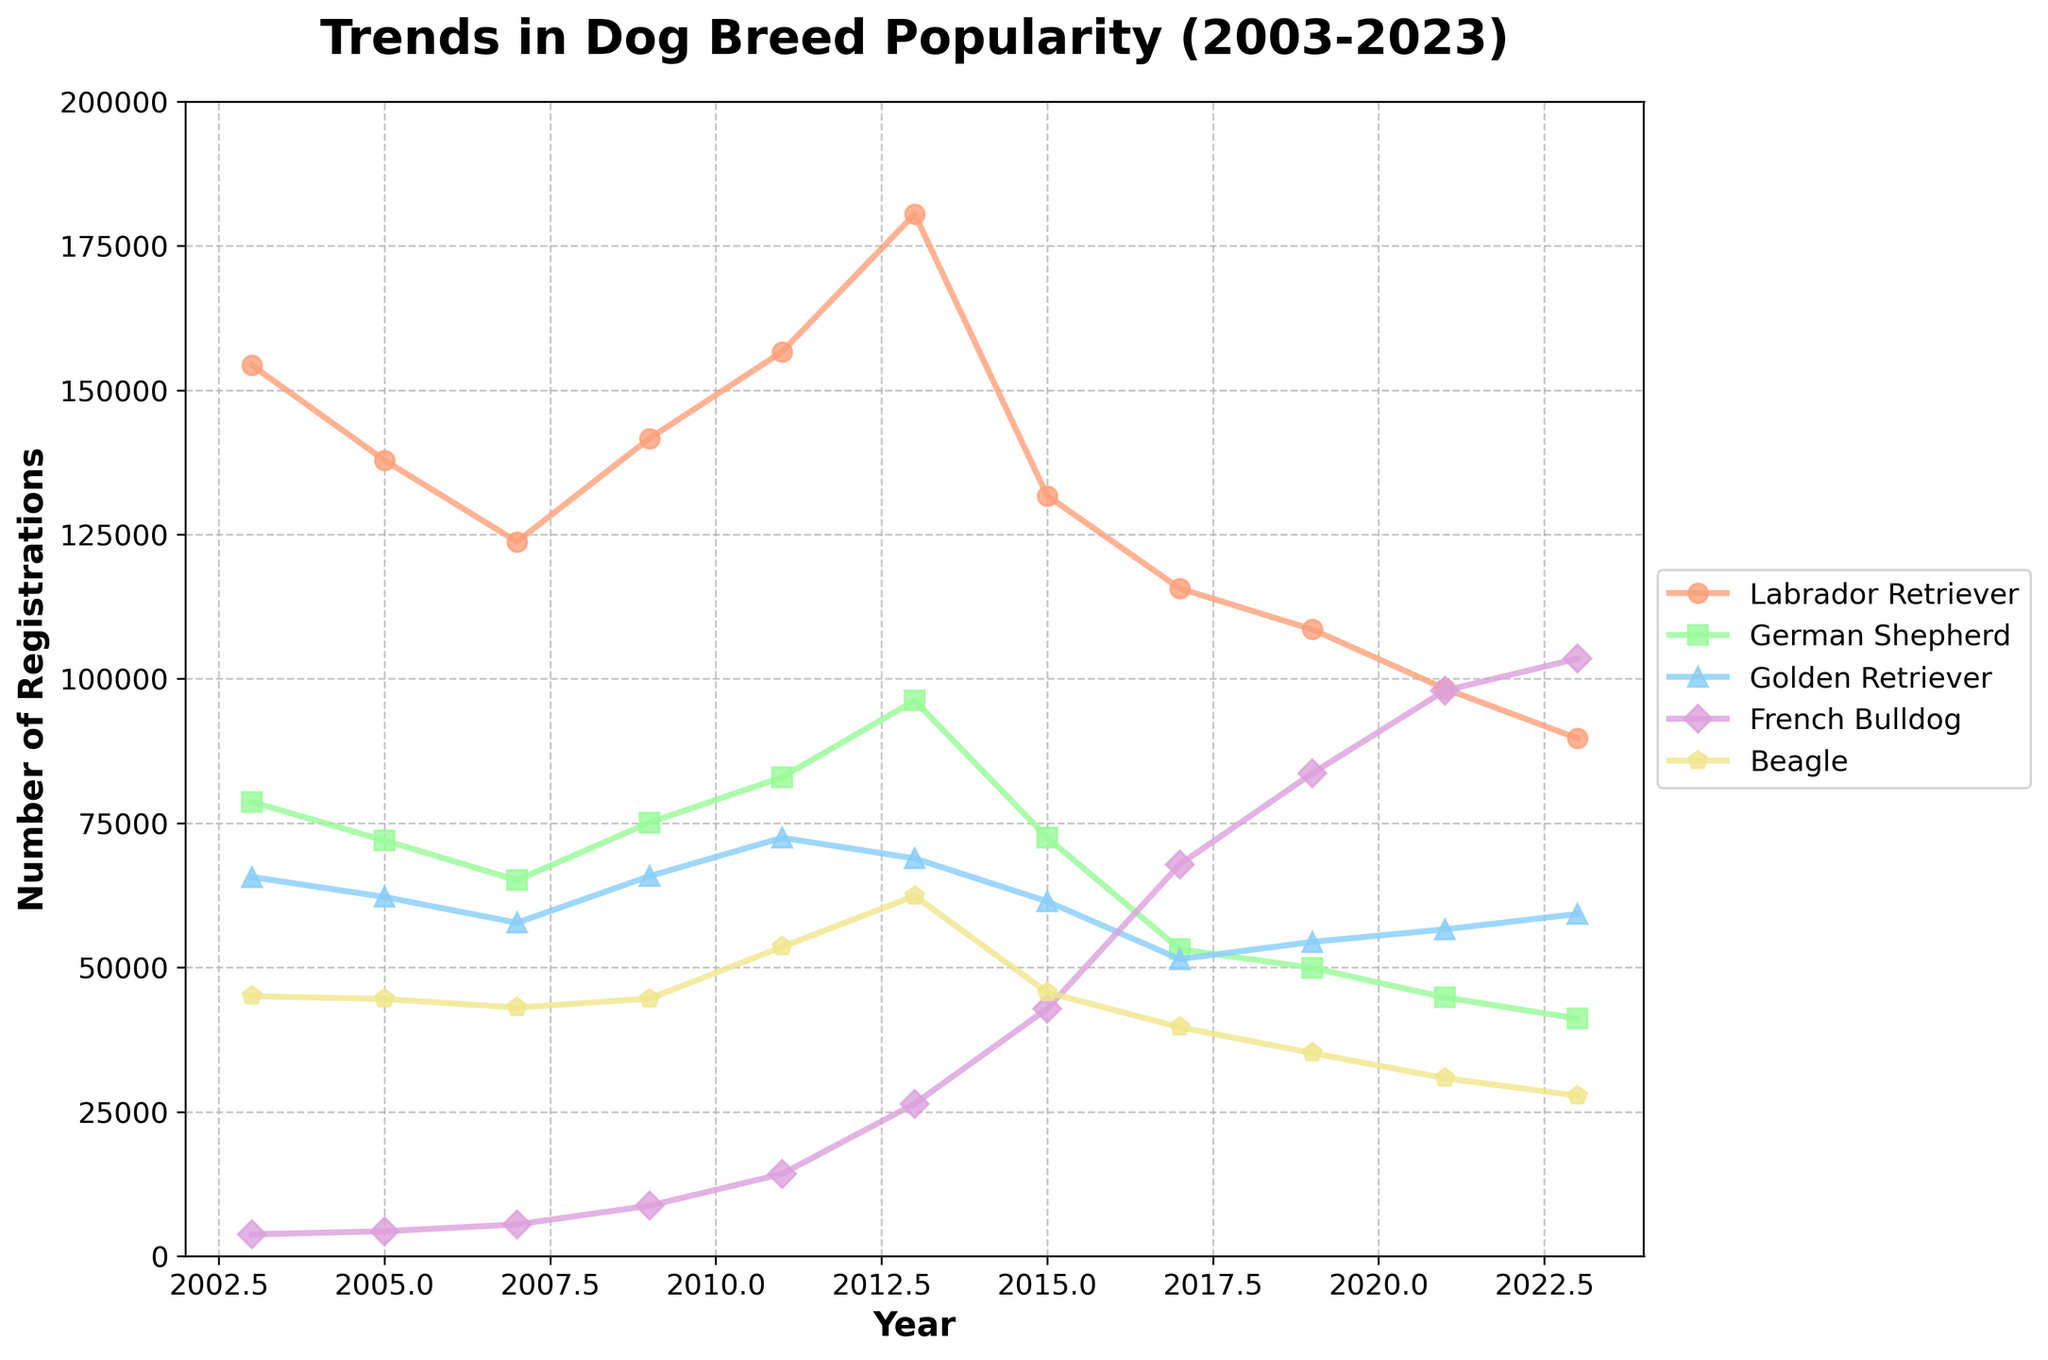What is the average number of registrations for Golden Retriever across all years? Sum all the data points for Golden Retriever and divide by the number of years (11). The numbers are 65672, 62226, 57750, 65828, 72476, 68899, 61452, 51454, 54435, 56615, 59277. The average calculation: (65672 + 62226 + 57750 + 65828 + 72476 + 68899 + 61452 + 51454 + 54435 + 56615 + 59277) / 11 = 61745.54
Answer: 61745.54 What's the combined registration number for all five breeds in 2011? Add the registration numbers for all breeds for the year 2011: Labrador Retriever (156660), German Shepherd (82962), Golden Retriever (72476), French Bulldog (14247), Beagle (53565). The sum is 156660 + 82962 + 72476 + 14247 + 53565 = 379910.
Answer: 379910 